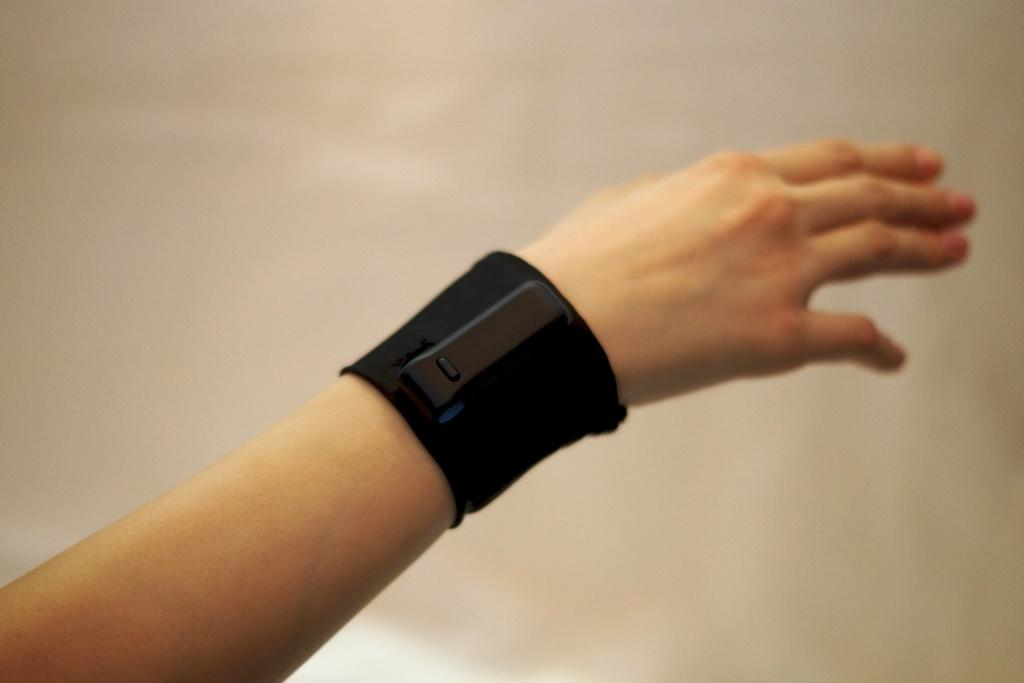What is the color of the wrist band in the image? The wrist band in the image is black. Where is the wrist band located on the person? The wrist band is on a person's hand. What type of pail is being used by the man in the image? There is no pail or man present in the image; it only features a black color wrist band on a person's hand. 